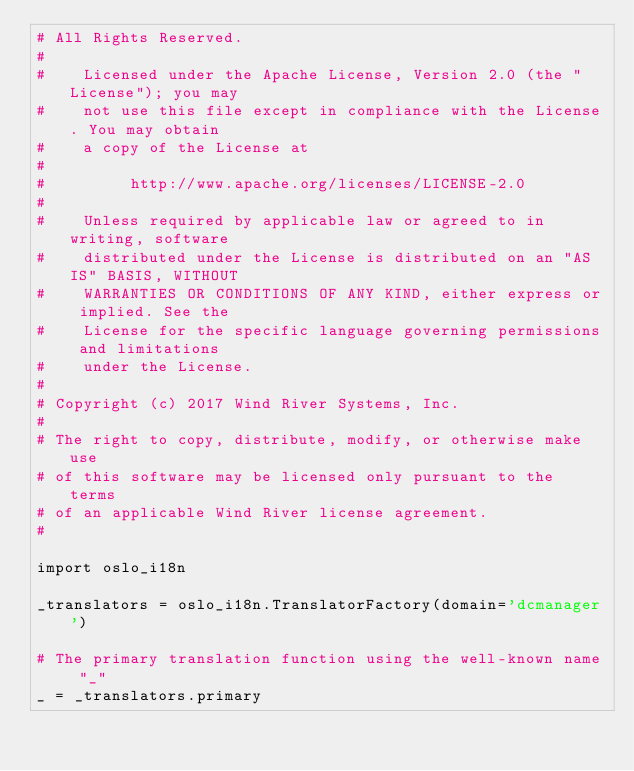<code> <loc_0><loc_0><loc_500><loc_500><_Python_># All Rights Reserved.
#
#    Licensed under the Apache License, Version 2.0 (the "License"); you may
#    not use this file except in compliance with the License. You may obtain
#    a copy of the License at
#
#         http://www.apache.org/licenses/LICENSE-2.0
#
#    Unless required by applicable law or agreed to in writing, software
#    distributed under the License is distributed on an "AS IS" BASIS, WITHOUT
#    WARRANTIES OR CONDITIONS OF ANY KIND, either express or implied. See the
#    License for the specific language governing permissions and limitations
#    under the License.
#
# Copyright (c) 2017 Wind River Systems, Inc.
#
# The right to copy, distribute, modify, or otherwise make use
# of this software may be licensed only pursuant to the terms
# of an applicable Wind River license agreement.
#

import oslo_i18n

_translators = oslo_i18n.TranslatorFactory(domain='dcmanager')

# The primary translation function using the well-known name "_"
_ = _translators.primary
</code> 